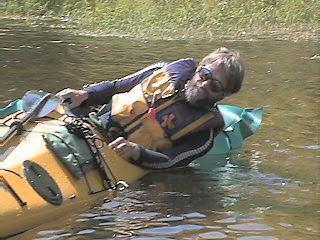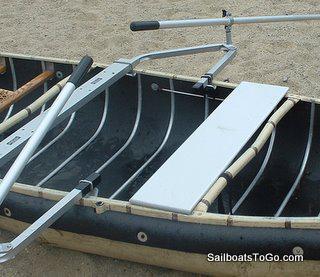The first image is the image on the left, the second image is the image on the right. Assess this claim about the two images: "An image shows a man without a cap sitting in a traditional canoe gripping an oar in each hand, with his arms and body in position to pull the oars back.". Correct or not? Answer yes or no. No. 